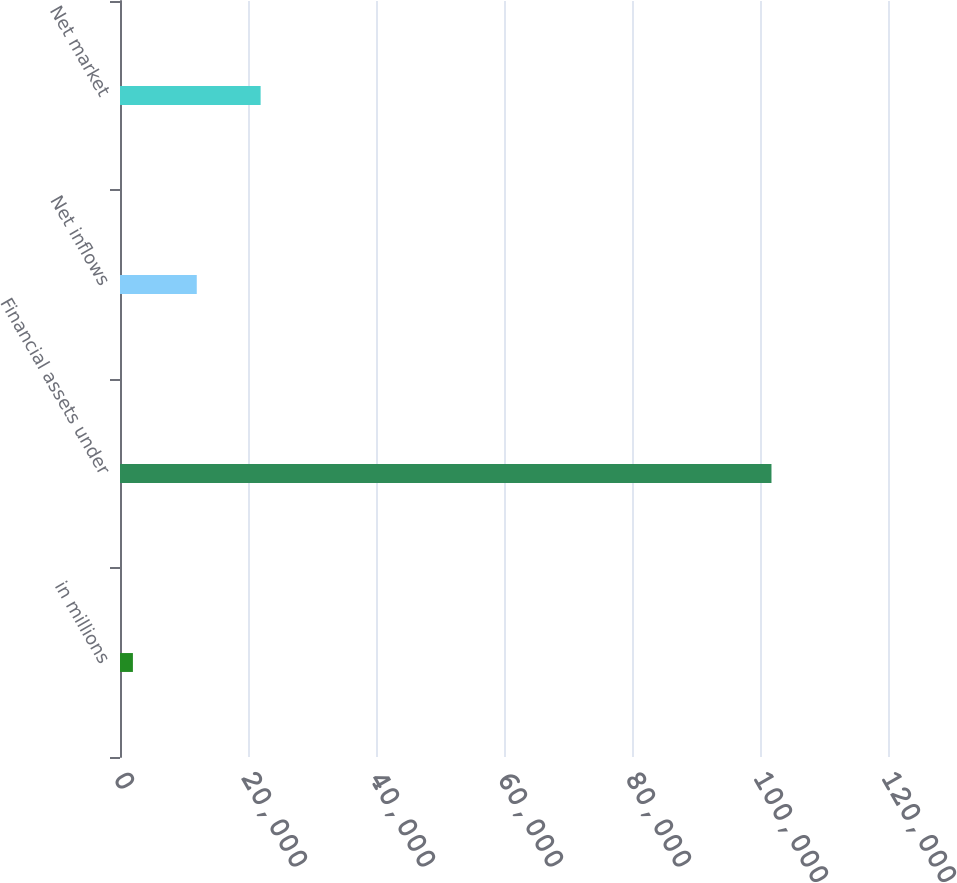Convert chart. <chart><loc_0><loc_0><loc_500><loc_500><bar_chart><fcel>in millions<fcel>Financial assets under<fcel>Net inflows<fcel>Net market<nl><fcel>2017<fcel>101793<fcel>11994.6<fcel>21972.2<nl></chart> 